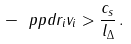Convert formula to latex. <formula><loc_0><loc_0><loc_500><loc_500>- \ p p d { r _ { i } } { v _ { i } } > \frac { c _ { s } } { l _ { \Delta } } \, .</formula> 